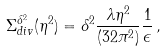Convert formula to latex. <formula><loc_0><loc_0><loc_500><loc_500>\Sigma _ { d i v } ^ { \delta ^ { 2 } } ( \eta ^ { 2 } ) = \delta ^ { 2 } \frac { \lambda \eta ^ { 2 } } { ( 3 2 \pi ^ { 2 } ) } \frac { 1 } { \epsilon } \, ,</formula> 